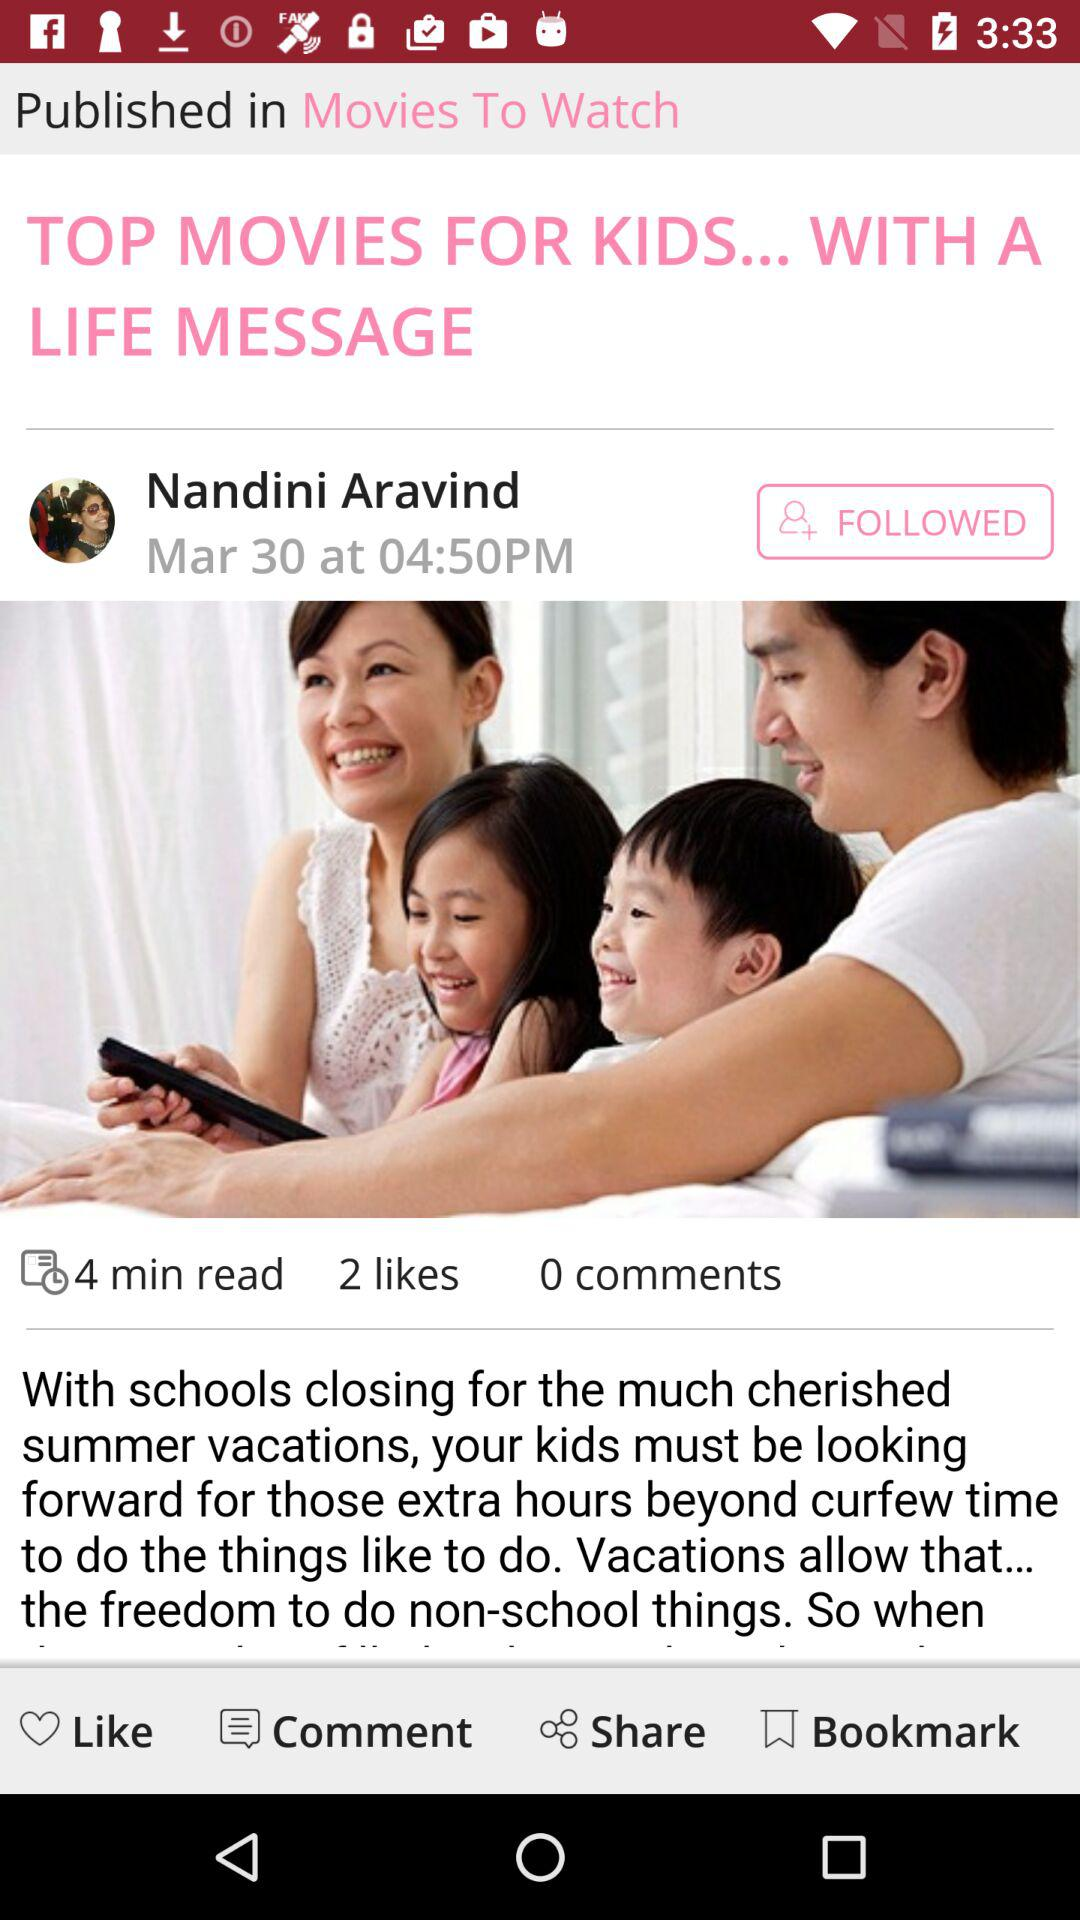When was the article published? The article was published on March 30 at 04:50 PM. 